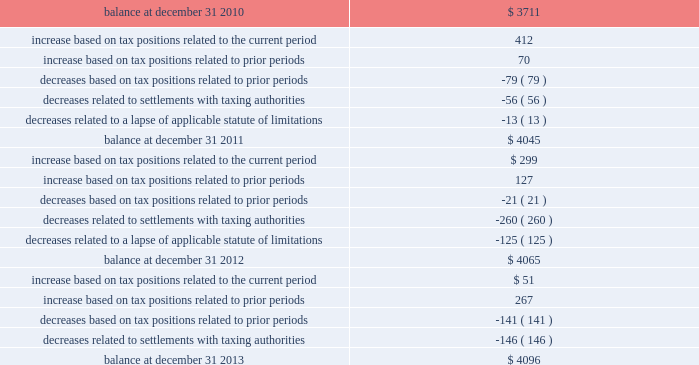Morgan stanley notes to consolidated financial statements 2014 ( continued ) the table presents a reconciliation of the beginning and ending amount of unrecognized tax benefits for 2013 , 2012 and 2011 ( dollars in millions ) : unrecognized tax benefits .
The company is under continuous examination by the irs and other tax authorities in certain countries , such as japan and the u.k. , and in states in which the company has significant business operations , such as new york .
The company is currently under review by the irs appeals office for the remaining issues covering tax years 1999 2013 2005 .
Also , the company is currently at various levels of field examination with respect to audits by the irs , as well as new york state and new york city , for tax years 2006 2013 2008 and 2007 2013 2009 , respectively .
During 2014 , the company expects to reach a conclusion with the u.k .
Tax authorities on substantially all issues through tax year 2010 .
The company believes that the resolution of tax matters will not have a material effect on the consolidated statements of financial condition of the company , although a resolution could have a material impact on the company 2019s consolidated statements of income for a particular future period and on the company 2019s effective income tax rate for any period in which such resolution occurs .
The company has established a liability for unrecognized tax benefits that the company believes is adequate in relation to the potential for additional assessments .
Once established , the company adjusts unrecognized tax benefits only when more information is available or when an event occurs necessitating a change .
The company periodically evaluates the likelihood of assessments in each taxing jurisdiction resulting from the expiration of the applicable statute of limitations or new information regarding the status of current and subsequent years 2019 examinations .
As part of the company 2019s periodic review , federal and state unrecognized tax benefits were released or remeasured .
As a result of this remeasurement , the income tax provision included a discrete tax benefit of $ 161 million and $ 299 million in 2013 and 2012 , respectively .
It is reasonably possible that the gross balance of unrecognized tax benefits of approximately $ 4.1 billion as of december 31 , 2013 may decrease significantly within the next 12 months due to an expected completion of the .
How many years are currently involved in tax controversies? 
Computations: (2010 - 1999)
Answer: 11.0. 